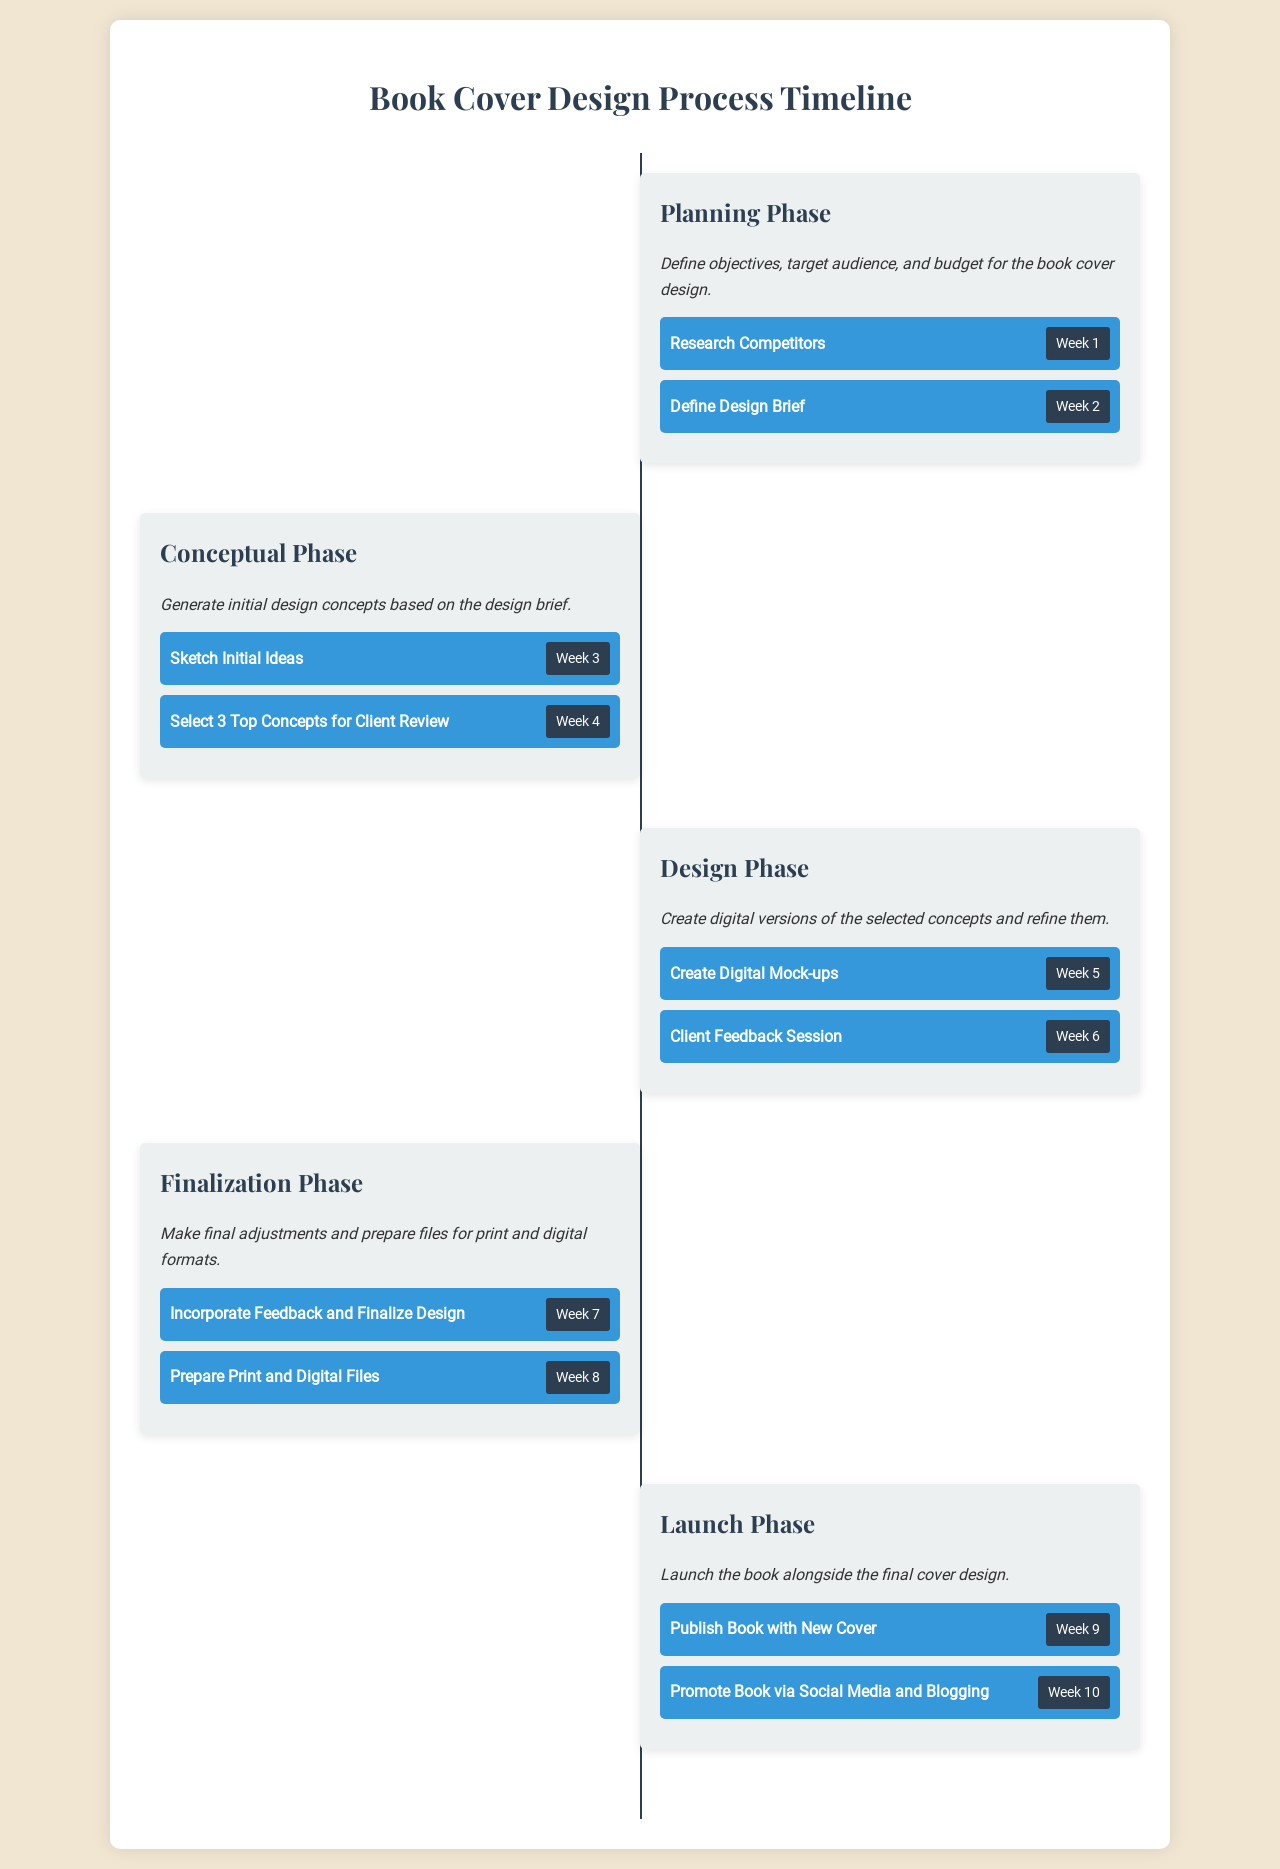What is the title of the document? The title of the document is indicated at the top of the rendered HTML, which is "Book Cover Design Process Timeline."
Answer: Book Cover Design Process Timeline How many phases are in the design process? The document outlines five distinct phases in the book cover design process.
Answer: Five What task is designated for Week 2? The task for Week 2 is indicated in the Planning Phase, which is to "Define Design Brief."
Answer: Define Design Brief In which week do clients provide feedback? The client feedback session is scheduled in Week 6, as stated in the Design Phase.
Answer: Week 6 What is the last milestone before the book launch? The last milestone before the launch is "Prepare Print and Digital Files," which occurs in Week 8 of the Finalization Phase.
Answer: Prepare Print and Digital Files What action happens during Week 10? Week 10 is designated for "Promote Book via Social Media and Blogging," as indicated in the Launch Phase.
Answer: Promote Book via Social Media and Blogging What is the primary activity described in the Conceptual Phase? The primary activity in the Conceptual Phase focuses on generating initial design concepts based on the design brief.
Answer: Generate initial design concepts Which phase includes researching competitors? Researching competitors is part of the Planning Phase, as stated in the first phase's milestones.
Answer: Planning Phase What is the purpose of the Launch Phase? The purpose of the Launch Phase is to launch the book alongside the final cover design, as described in the phase's summary.
Answer: Launch the book alongside the final cover design 